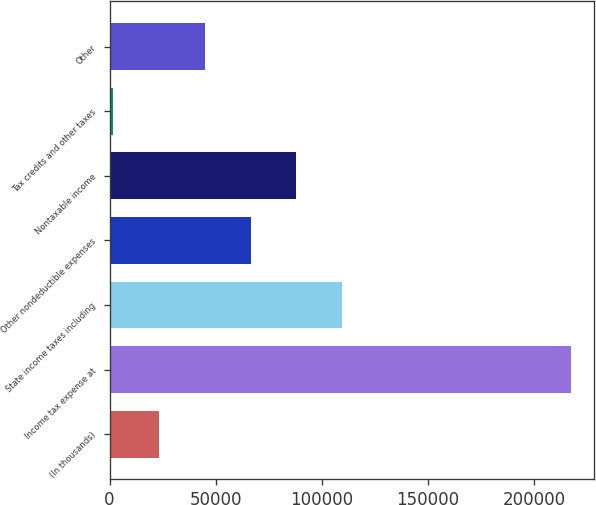<chart> <loc_0><loc_0><loc_500><loc_500><bar_chart><fcel>(In thousands)<fcel>Income tax expense at<fcel>State income taxes including<fcel>Other nondeductible expenses<fcel>Nontaxable income<fcel>Tax credits and other taxes<fcel>Other<nl><fcel>23295.1<fcel>217498<fcel>109608<fcel>66451.3<fcel>88029.4<fcel>1717<fcel>44873.2<nl></chart> 